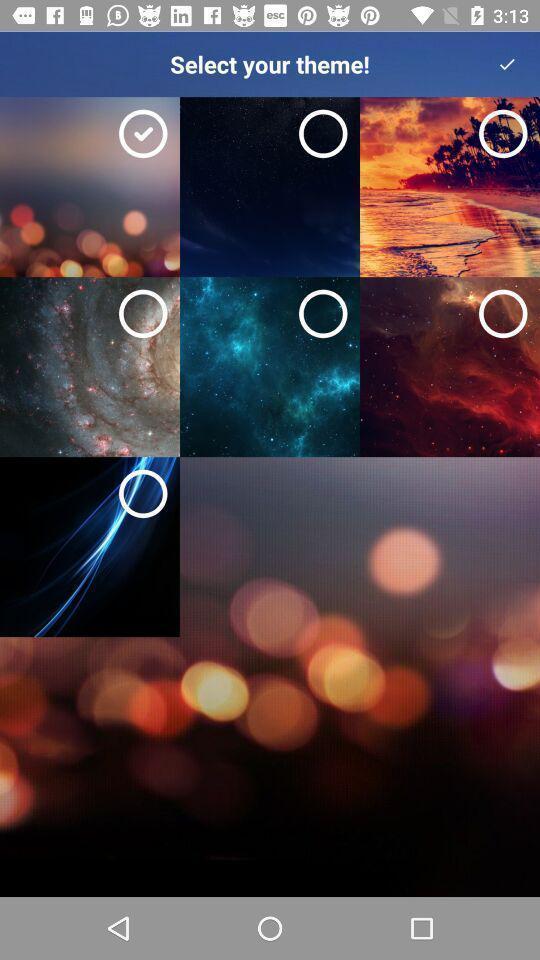Summarize the main components in this picture. Page showing theme options for mobile. 